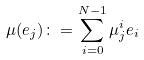Convert formula to latex. <formula><loc_0><loc_0><loc_500><loc_500>\mu ( e _ { j } ) \colon = \sum _ { i = 0 } ^ { N - 1 } \mu ^ { i } _ { j } e _ { i }</formula> 